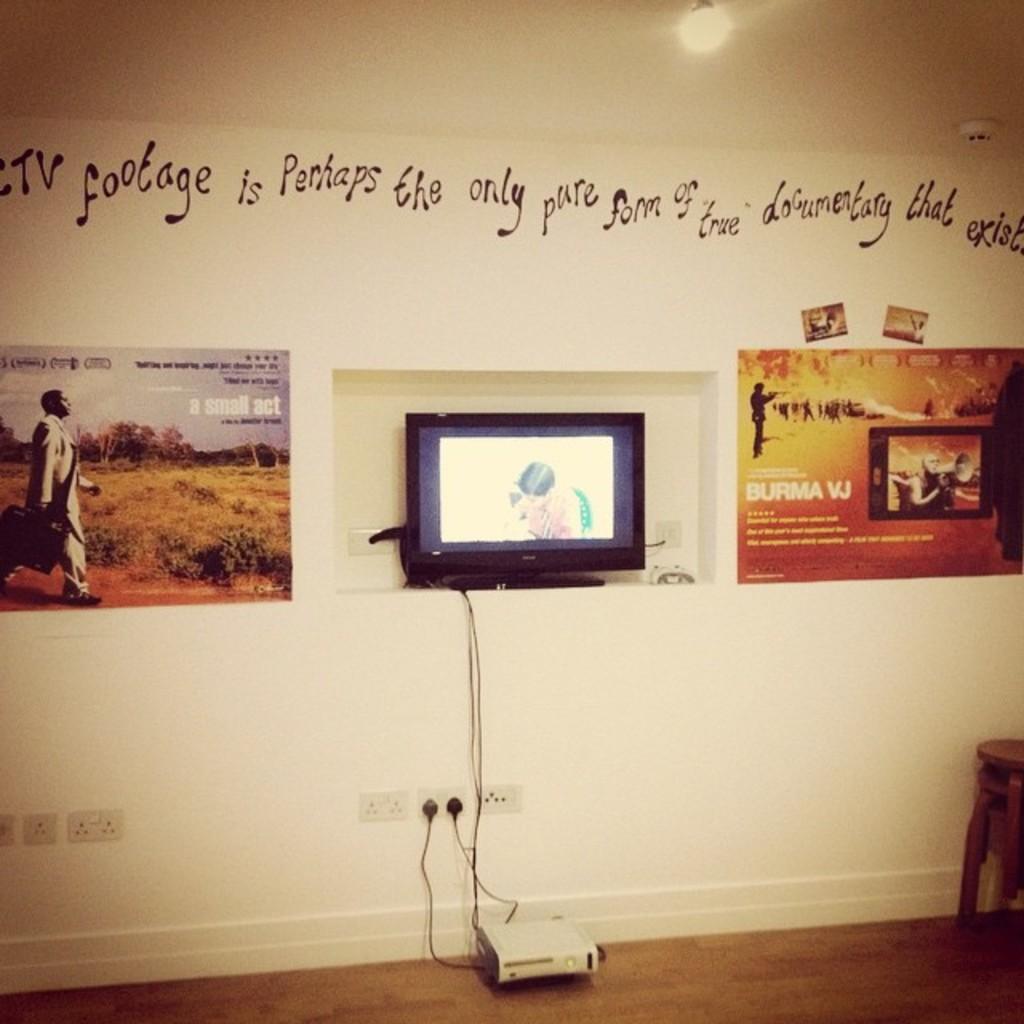What does it say on the top of the wall?
Your answer should be very brief. Ctv footage is perhaps the only pure form of true documentary that exists. 